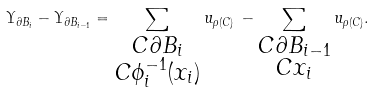<formula> <loc_0><loc_0><loc_500><loc_500>\Upsilon _ { \partial B _ { i } } - \Upsilon _ { \partial B _ { i - 1 } } = \sum _ { \substack { C \partial B _ { i } \\ C \phi _ { i } ^ { - 1 } ( x _ { i } ) } } u _ { \rho ( C ) } \, - \sum _ { \substack { C \partial B _ { i - 1 } \\ C x _ { i } } } u _ { \rho ( C ) } .</formula> 